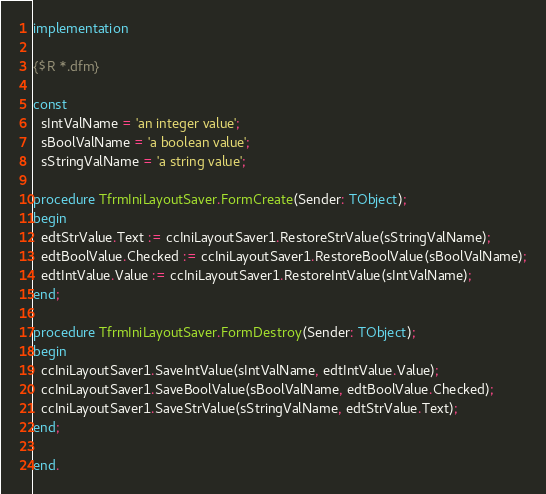<code> <loc_0><loc_0><loc_500><loc_500><_Pascal_>
implementation

{$R *.dfm}

const
  sIntValName = 'an integer value';
  sBoolValName = 'a boolean value';
  sStringValName = 'a string value';

procedure TfrmIniLayoutSaver.FormCreate(Sender: TObject);
begin
  edtStrValue.Text := ccIniLayoutSaver1.RestoreStrValue(sStringValName);
  edtBoolValue.Checked := ccIniLayoutSaver1.RestoreBoolValue(sBoolValName);
  edtIntValue.Value := ccIniLayoutSaver1.RestoreIntValue(sIntValName);
end;

procedure TfrmIniLayoutSaver.FormDestroy(Sender: TObject);
begin
  ccIniLayoutSaver1.SaveIntValue(sIntValName, edtIntValue.Value);
  ccIniLayoutSaver1.SaveBoolValue(sBoolValName, edtBoolValue.Checked);
  ccIniLayoutSaver1.SaveStrValue(sStringValName, edtStrValue.Text);
end;

end.
</code> 